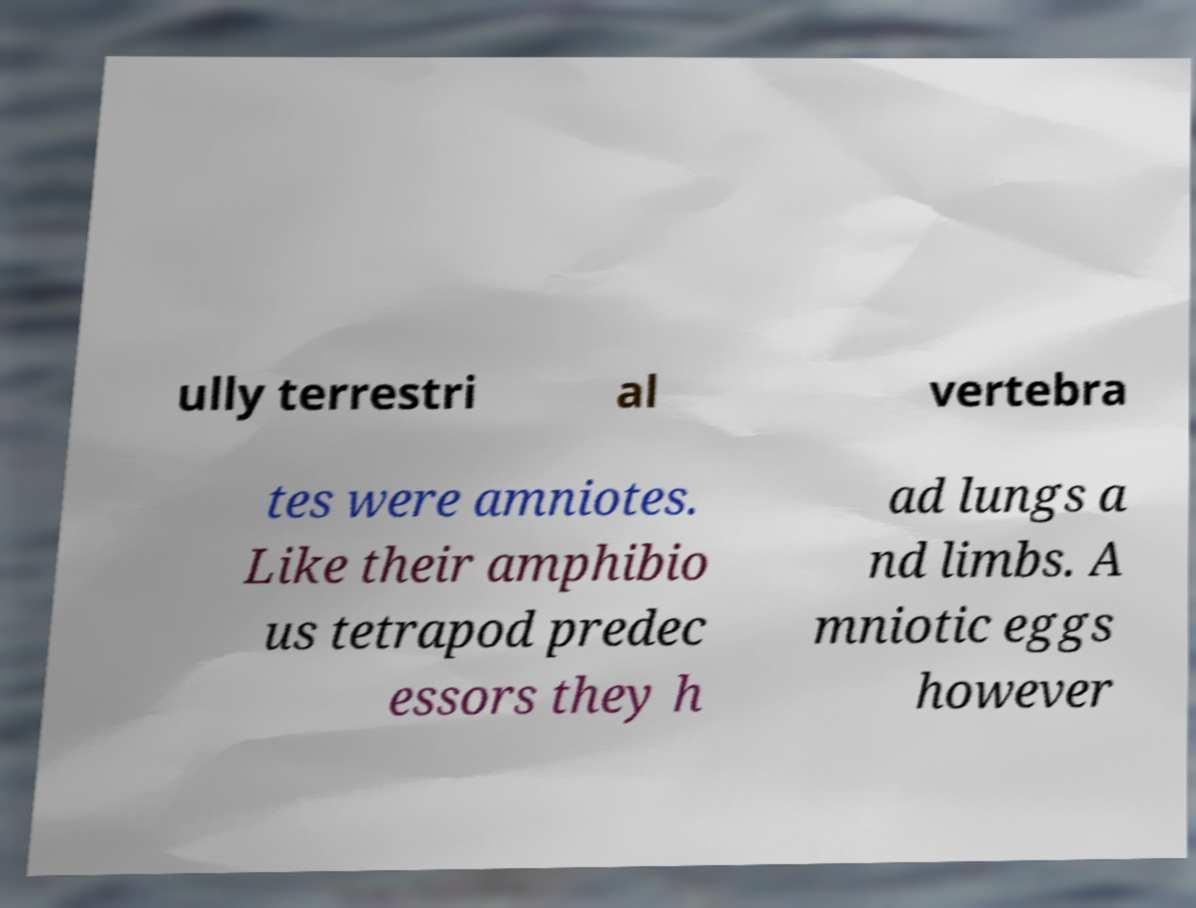Could you assist in decoding the text presented in this image and type it out clearly? ully terrestri al vertebra tes were amniotes. Like their amphibio us tetrapod predec essors they h ad lungs a nd limbs. A mniotic eggs however 